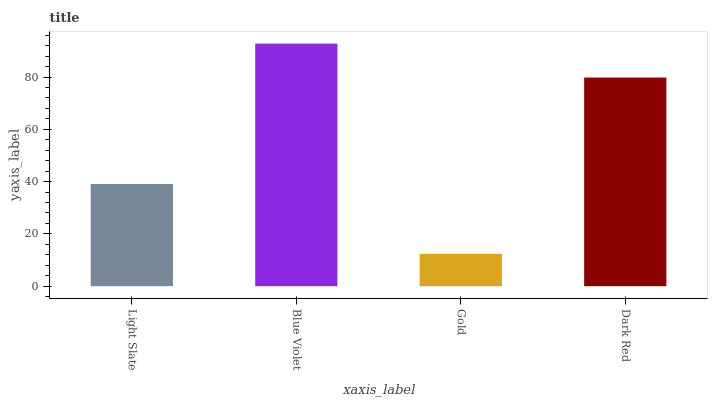Is Gold the minimum?
Answer yes or no. Yes. Is Blue Violet the maximum?
Answer yes or no. Yes. Is Blue Violet the minimum?
Answer yes or no. No. Is Gold the maximum?
Answer yes or no. No. Is Blue Violet greater than Gold?
Answer yes or no. Yes. Is Gold less than Blue Violet?
Answer yes or no. Yes. Is Gold greater than Blue Violet?
Answer yes or no. No. Is Blue Violet less than Gold?
Answer yes or no. No. Is Dark Red the high median?
Answer yes or no. Yes. Is Light Slate the low median?
Answer yes or no. Yes. Is Light Slate the high median?
Answer yes or no. No. Is Dark Red the low median?
Answer yes or no. No. 